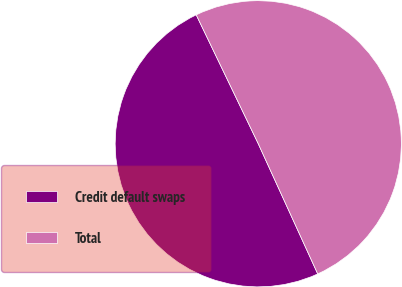Convert chart to OTSL. <chart><loc_0><loc_0><loc_500><loc_500><pie_chart><fcel>Credit default swaps<fcel>Total<nl><fcel>49.68%<fcel>50.32%<nl></chart> 